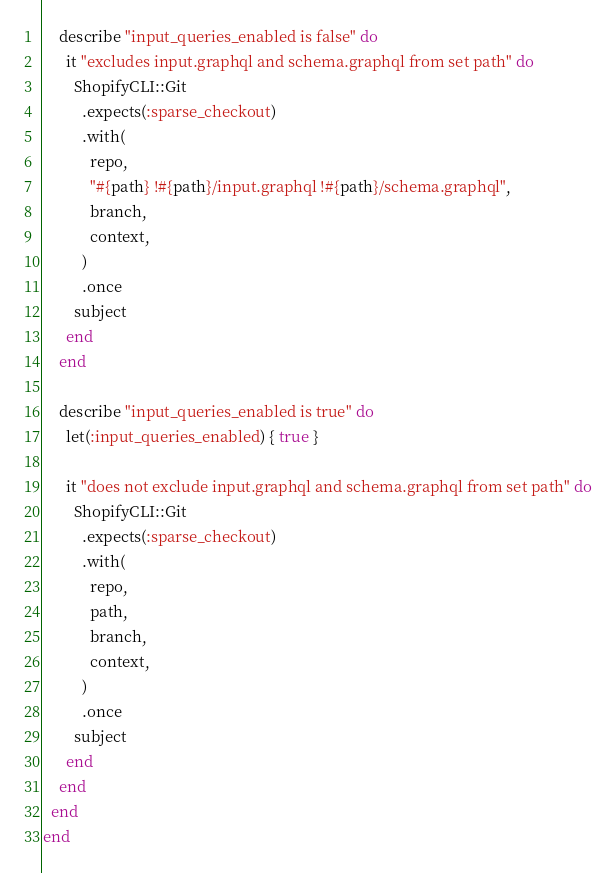<code> <loc_0><loc_0><loc_500><loc_500><_Ruby_>    describe "input_queries_enabled is false" do
      it "excludes input.graphql and schema.graphql from set path" do
        ShopifyCLI::Git
          .expects(:sparse_checkout)
          .with(
            repo,
            "#{path} !#{path}/input.graphql !#{path}/schema.graphql",
            branch,
            context,
          )
          .once
        subject
      end
    end

    describe "input_queries_enabled is true" do
      let(:input_queries_enabled) { true }

      it "does not exclude input.graphql and schema.graphql from set path" do
        ShopifyCLI::Git
          .expects(:sparse_checkout)
          .with(
            repo,
            path,
            branch,
            context,
          )
          .once
        subject
      end
    end
  end
end
</code> 